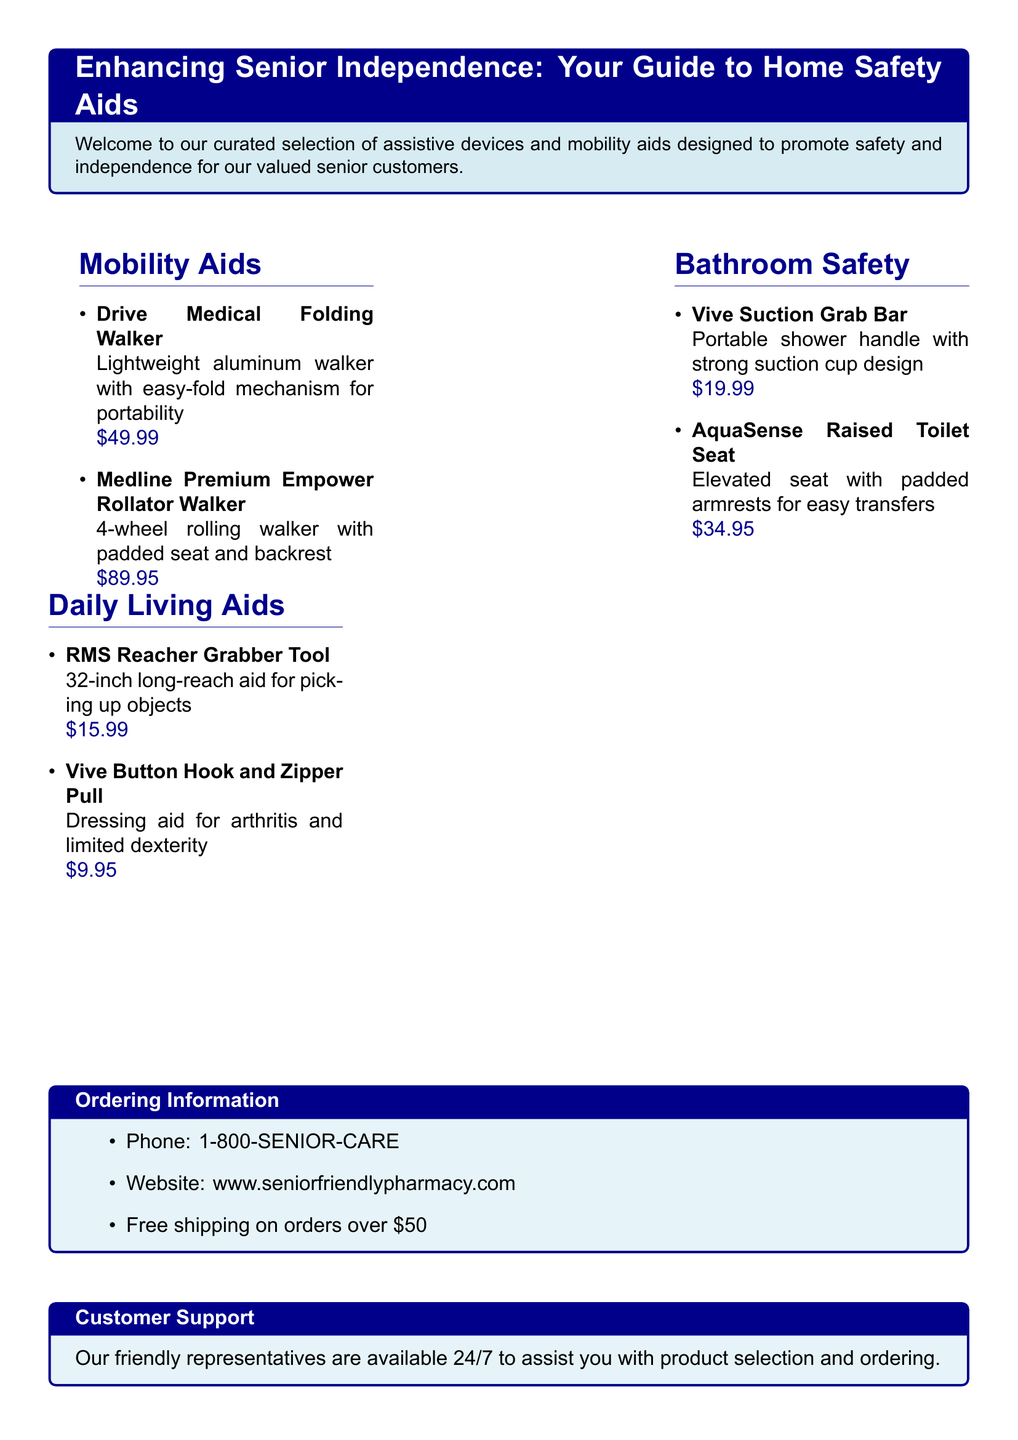What is the price of the Drive Medical Folding Walker? The price is listed next to the product name in the mobility aids section, which is $49.99.
Answer: $49.99 How many wheels does the Medline Premium Empower Rollator Walker have? The number of wheels is mentioned in the description of the product, which specifies it as a 4-wheel walker.
Answer: 4 wheels What is the purpose of the Vive Suction Grab Bar? The purpose is stated in the description as providing a portable shower handle for safety in the bathroom.
Answer: Shower handle What type of aid is the RMS Reacher Grabber Tool? The tool is categorized in the daily living aids section, described as a long-reach aid for picking up objects.
Answer: Long-reach aid Is there free shipping on orders over $50? Shipping information section states that free shipping is available on orders exceeding $50.
Answer: Yes 